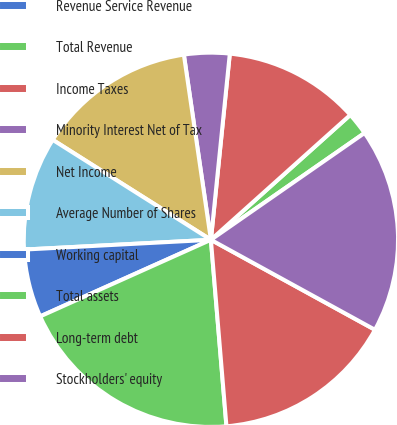Convert chart. <chart><loc_0><loc_0><loc_500><loc_500><pie_chart><fcel>Revenue Service Revenue<fcel>Total Revenue<fcel>Income Taxes<fcel>Minority Interest Net of Tax<fcel>Net Income<fcel>Average Number of Shares<fcel>Working capital<fcel>Total assets<fcel>Long-term debt<fcel>Stockholders' equity<nl><fcel>0.0%<fcel>1.96%<fcel>11.76%<fcel>3.92%<fcel>13.72%<fcel>9.8%<fcel>5.88%<fcel>19.61%<fcel>15.69%<fcel>17.65%<nl></chart> 